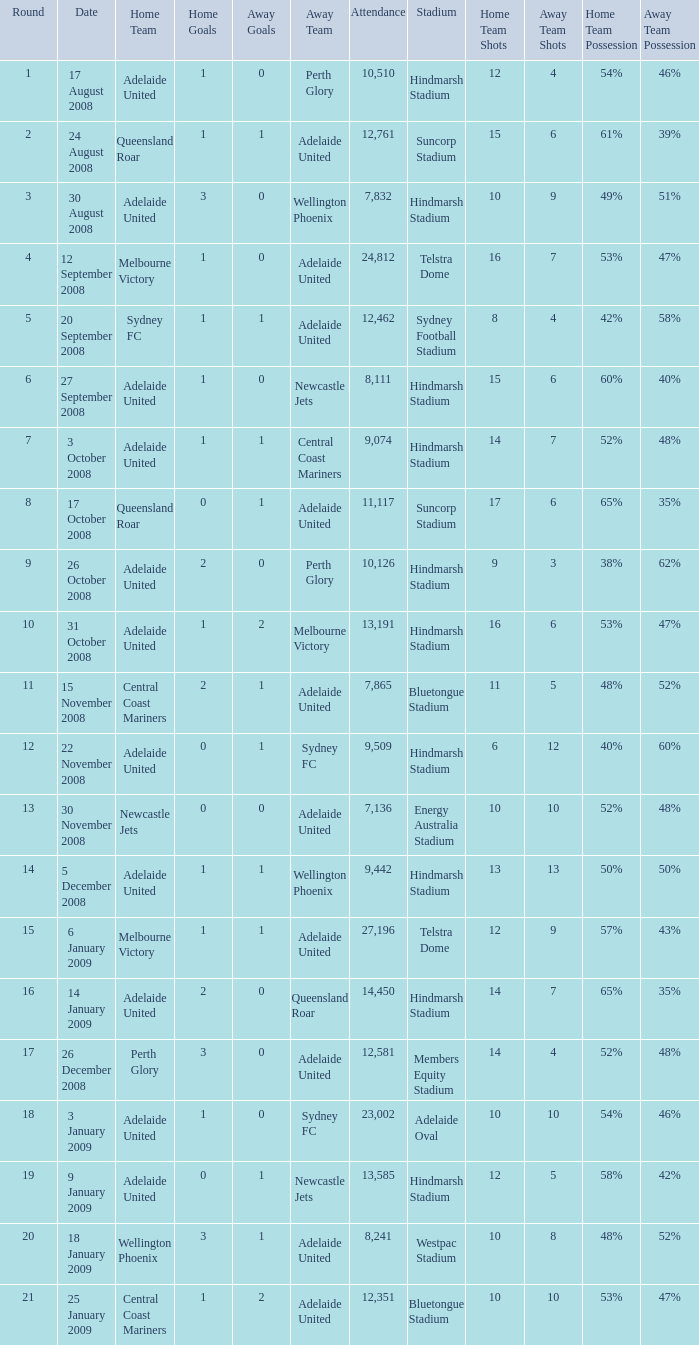What is the round when 11,117 people attended the game on 26 October 2008? 9.0. 